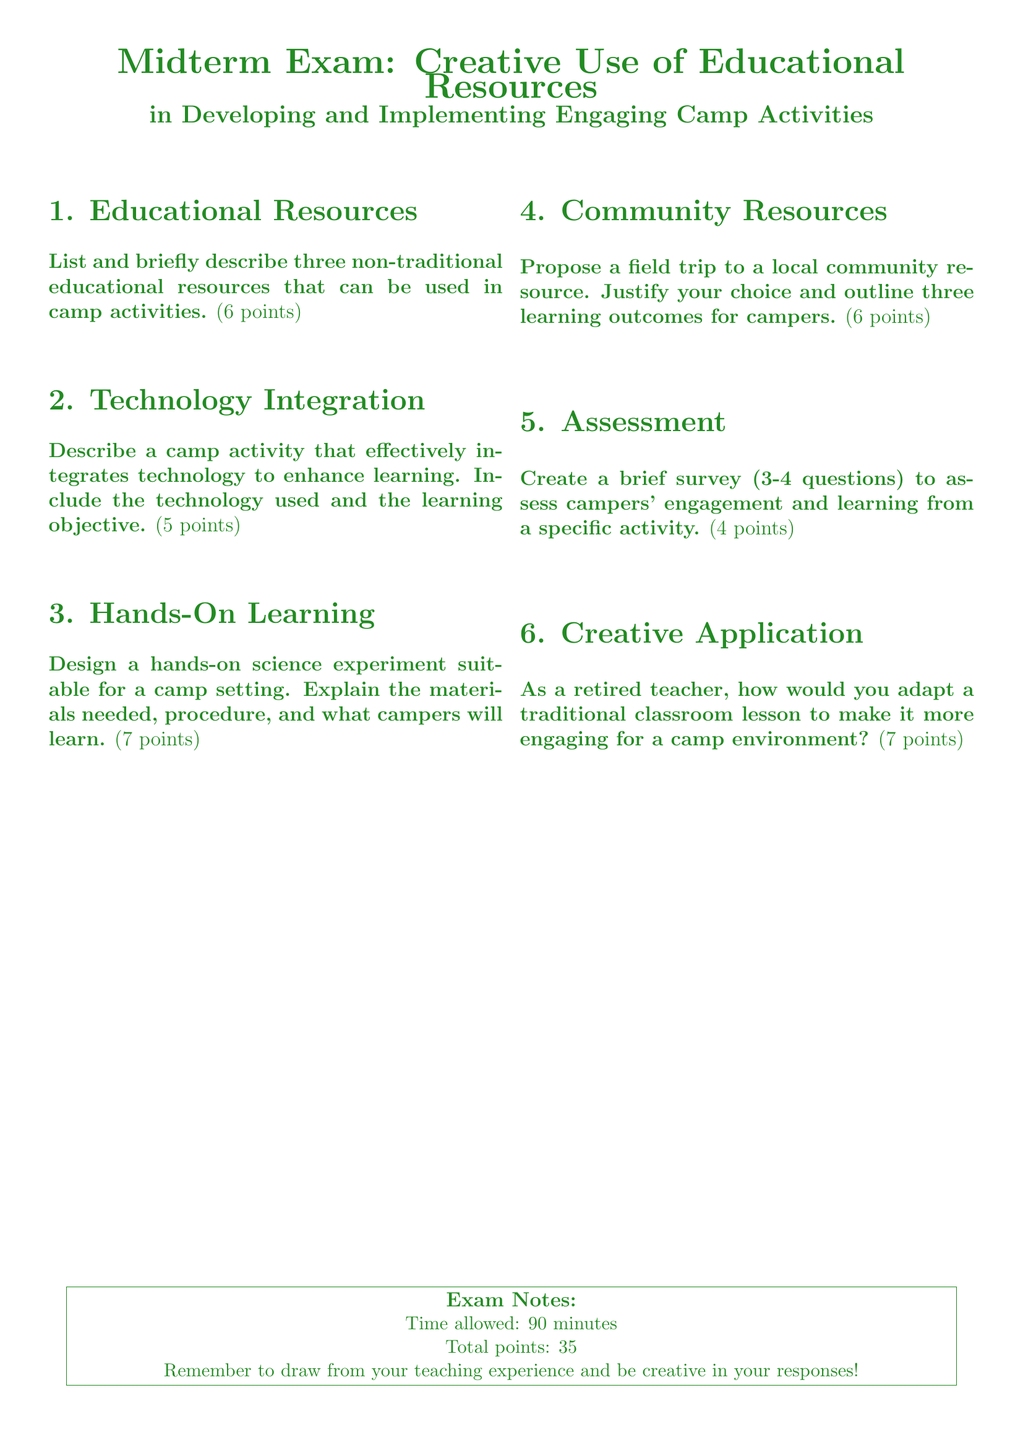What is the total number of points for the exam? The total points for the exam is clearly stated at the bottom of the document.
Answer: 35 How much time is allowed for the exam? The time allowed for completing the exam is indicated in the exam notes section.
Answer: 90 minutes What is the main theme of the midterm exam? The title of the exam provides insight into its primary focus area, which combines education and camp activities.
Answer: Creative Use of Educational Resources How many hands-on learning questions are there? By counting the sections, we can see that only one question specifically addresses hands-on learning in the document.
Answer: 1 What is the maximum score for the hands-on science experiment question? The document assigns a specific point value to the hands-on science experiment question.
Answer: 7 points What resource type is proposed for the field trip? The type of resource to be proposed for the field trip is derived from the document's requirement in section 4.
Answer: Local community resource What is the required number of questions for the camper engagement survey? The document specifies the number of questions needed for the survey assessing campers' engagement.
Answer: 3-4 questions What kind of lesson adaptation is mentioned for engagement? The question in section 6 explicitly asks about adapting a traditional lesson, indicating the type of lesson discussed.
Answer: Traditional classroom lesson 